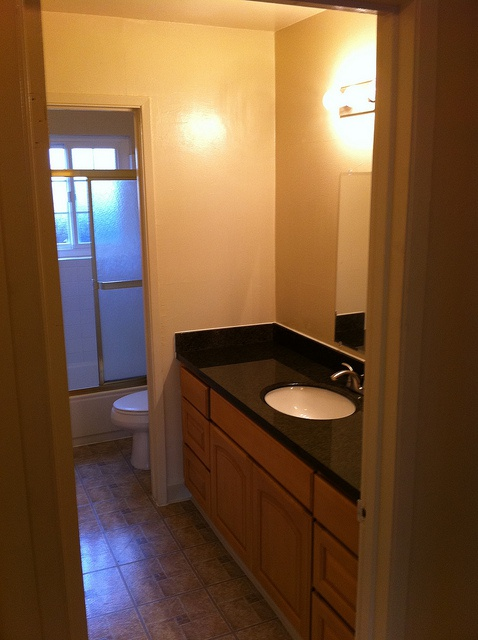Describe the objects in this image and their specific colors. I can see sink in maroon, black, and tan tones and toilet in maroon, brown, black, and gray tones in this image. 